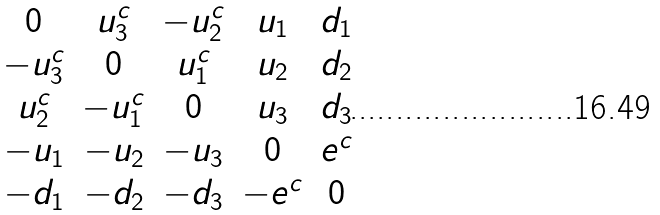Convert formula to latex. <formula><loc_0><loc_0><loc_500><loc_500>\begin{matrix} 0 & u ^ { c } _ { 3 } & - u ^ { c } _ { 2 } & u _ { 1 } & d _ { 1 } \\ - u ^ { c } _ { 3 } & 0 & u ^ { c } _ { 1 } & u _ { 2 } & d _ { 2 } \\ u ^ { c } _ { 2 } & - u ^ { c } _ { 1 } & 0 & u _ { 3 } & d _ { 3 } \\ - u _ { 1 } & - u _ { 2 } & - u _ { 3 } & 0 & e ^ { c } \\ - d _ { 1 } & - d _ { 2 } & - d _ { 3 } & - e ^ { c } & 0 \end{matrix}</formula> 